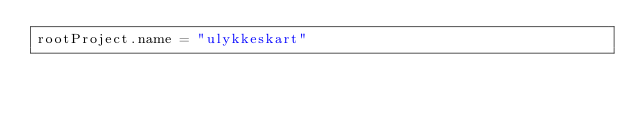<code> <loc_0><loc_0><loc_500><loc_500><_Kotlin_>rootProject.name = "ulykkeskart"
</code> 